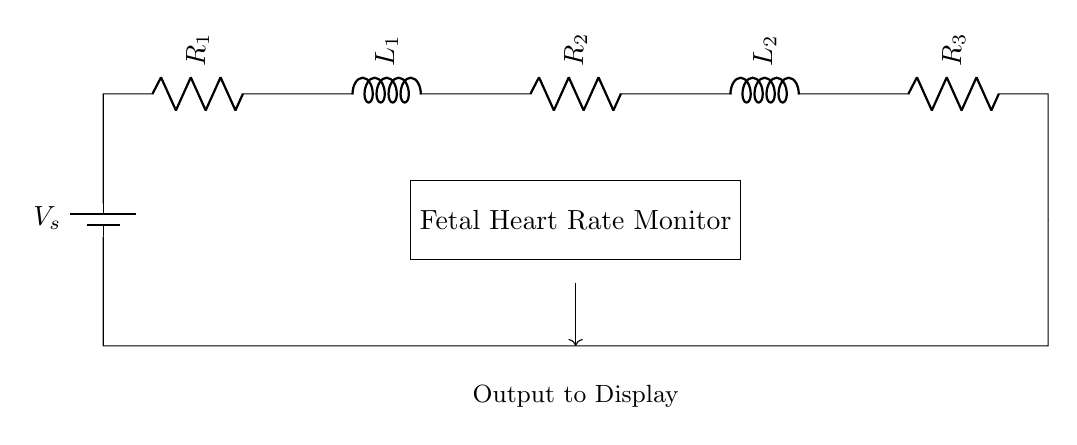What is the total number of resistors in this circuit? The circuit diagram shows three resistors labeled R1, R2, and R3. By counting the distinct resistor symbols in the diagram, we find that there are three.
Answer: three What is the purpose of the inductors in this circuit? Inductors L1 and L2 in the circuit are used to limit the rate of change of current, which can help stabilize the output signal for the monitor. They store energy in a magnetic field and are integral to the functioning of the fetal heart rate monitor.
Answer: stabilize output Which components are connected in series between the battery and the fetal heart rate monitor? The components connected in series are the voltage source, followed by resistors R1, R2, R3, and inductors L1, L2, in that order. These components collectively create a single path for current to flow to the fetal heart rate monitor.
Answer: voltage source, resistors, inductors What is the function of the fetal heart rate monitor in this circuit? The fetal heart rate monitor is designed to receive the electrical signals processed through the circuit, which represent the fetal heart rate, and then display this information for medical practitioners to observe and analyze.
Answer: display fetal heart rate How would the total resistance change if one resistor is removed from the circuit? In a series circuit, the total resistance is the sum of all individual resistances. If one resistor is removed, the total resistance would decrease by the value of that resistor, leading to an increase in current flow according to Ohm's Law (I = V/R).
Answer: total resistance decreases What happens to the current if the voltage source is increased? According to Ohm's Law, if the voltage source is increased while resistance remains constant, the current flowing through the circuit will increase proportionally. This is a fundamental principle of electric circuits.
Answer: current increases 